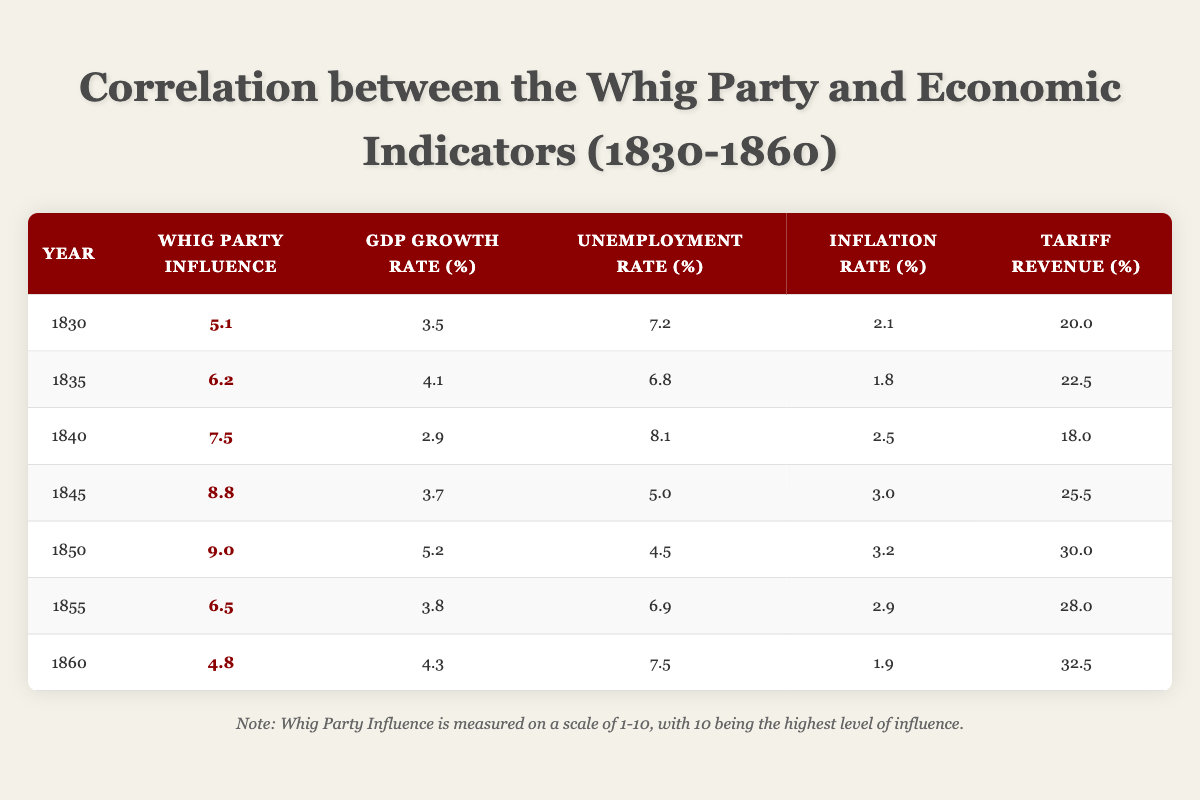What was the Whig Party influence in 1850? The table shows that in 1850, the Whig Party Influence was 9.0.
Answer: 9.0 In which year did the GDP growth rate reach its highest point? The GDP growth rate was highest at 5.2 in 1850 according to the table.
Answer: 1850 What is the average inflation rate over these years? To calculate the average inflation rate: (2.1 + 1.8 + 2.5 + 3.0 + 3.2 + 2.9 + 1.9) = 17.4, then divide by 7 data points which gives 17.4/7 = 2.49.
Answer: 2.49 Was there a decrease in Whig Party influence from 1845 to 1855? Yes, the Whig Party influence decreased from 8.8 in 1845 to 6.5 in 1855, indicating a decline during that period.
Answer: Yes What was the change in unemployment rate from 1830 to 1860? The unemployment rate in 1830 was 7.2 and in 1860 it was 7.5. The change is calculated as 7.5 - 7.2 = 0.3, indicating an increase.
Answer: 0.3 How do the tariff revenues compare in 1835 and 1840? The table shows that tariff revenue in 1835 was 22.5 while in 1840 it was 18.0, which indicates that tariff revenue decreased by 4.5 from 1835 to 1840.
Answer: Decreased by 4.5 In which year did the unemployment rate reach the lowest level? The lowest unemployment rate recorded was 4.5 in 1850 as per the data in the table.
Answer: 1850 What is the overall trend in Whig Party influence from 1830 to 1860? Observing the Whig Party influence column, there is an initial increase from 5.1 in 1830 to 9.0 in 1850, followed by a decline to 4.8 in 1860, indicating a peak followed by a downward trend.
Answer: Initial increase then a decline Was the GDP growth rate higher on average than the inflation rate from 1830 to 1860? The average GDP growth rate is (3.5 + 4.1 + 2.9 + 3.7 + 5.2 + 3.8 + 4.3) = 27.5, which leads to 27.5/7 = 3.93. The average inflation rate is already calculated as 2.49, so yes, the GDP growth rate is higher than the inflation rate.
Answer: Yes 